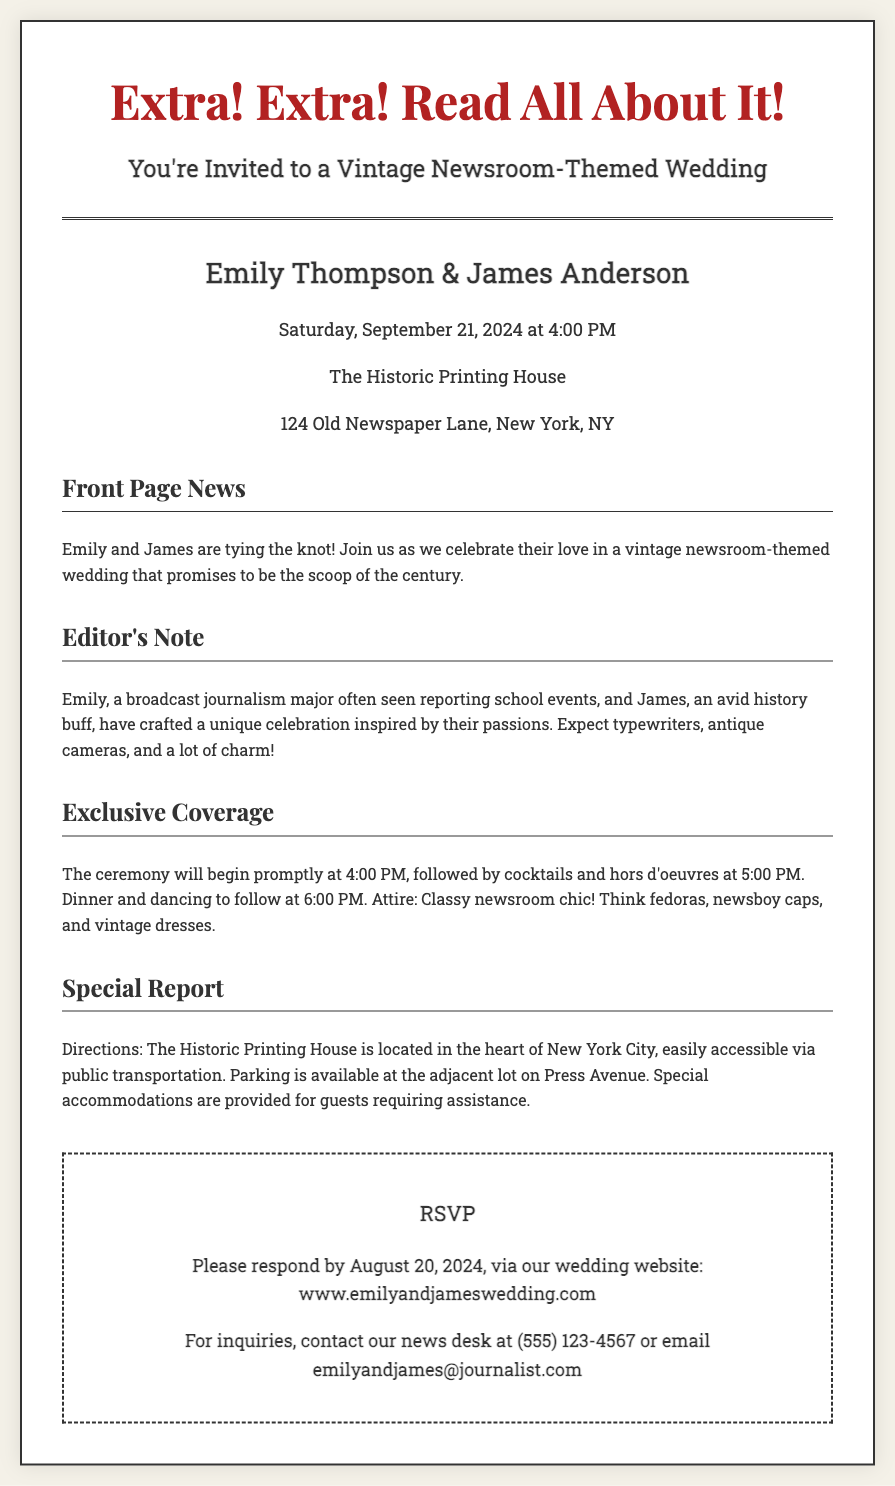What are the names of the couple? The document states the couple's names in the section with the couple's name highlighted.
Answer: Emily Thompson & James Anderson What is the date of the wedding? The wedding date is mentioned in the event details section of the invitation.
Answer: Saturday, September 21, 2024 What time does the ceremony begin? The document provides the start time of the ceremony in the Exclusive Coverage section.
Answer: 4:00 PM What is the address of the venue? The specific location of the wedding venue is stated in the event details section.
Answer: 124 Old Newspaper Lane, New York, NY What is the theme of the wedding? The invitation explicitly states the theme in the title and header sections.
Answer: Vintage Newsroom Why is Emily’s choice of major relevant? It connects her background in journalism to the wedding theme, adding a personal touch to the invitation.
Answer: Unique celebration inspired by their passions What kind of attire is suggested? The Exclusive Coverage section describes the expected dress code for guests.
Answer: Classy newsroom chic When is the RSVP deadline? The RSVP deadline is mentioned clearly in the RSVP section of the document.
Answer: August 20, 2024 What type of transportation is available to the venue? The Special Report section provides information about the accessibility of the venue via public transport.
Answer: Public transportation How can guests contact for inquiries? The RSVP section includes contact details for guests who have inquiries regarding the wedding.
Answer: (555) 123-4567 or email emilyandjames@journalist.com 